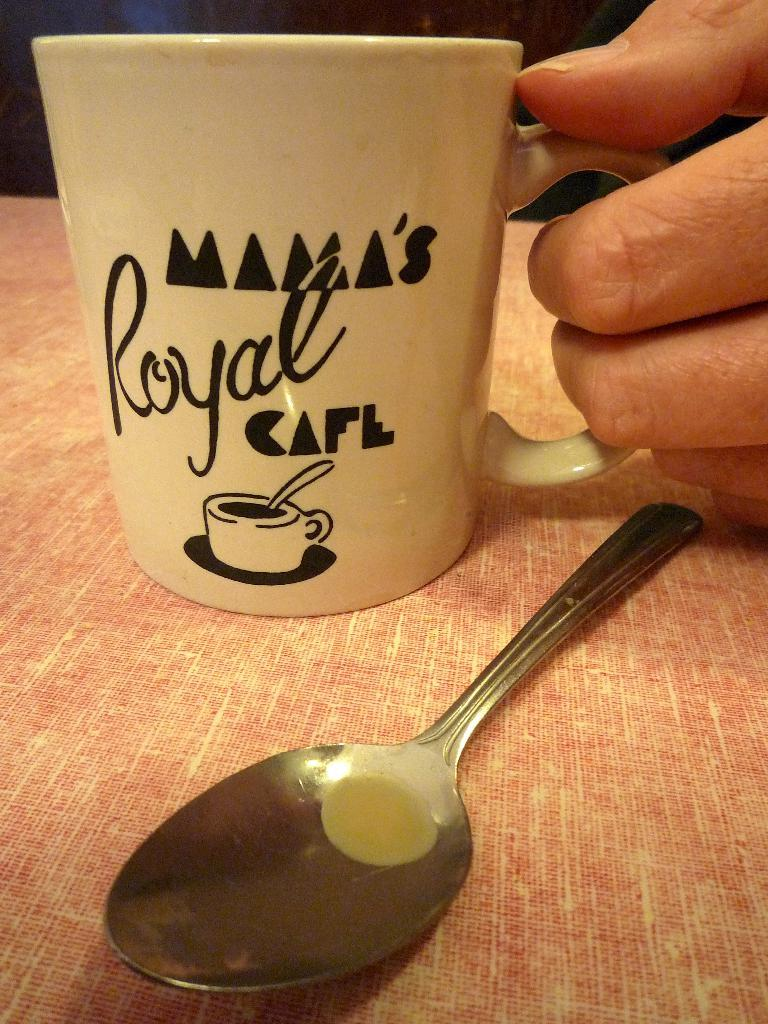What is the person holding in the image? There is a person's hand holding a mug in the image. What object is placed on the table in the image? There is a spoon placed on the table in the image. What type of insect can be seen crawling on the person's hand in the image? There is no insect present on the person's hand in the image. 